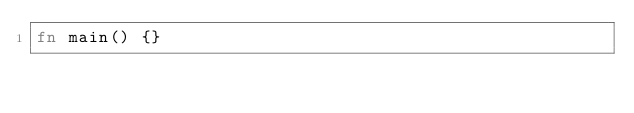Convert code to text. <code><loc_0><loc_0><loc_500><loc_500><_Rust_>fn main() {}
</code> 